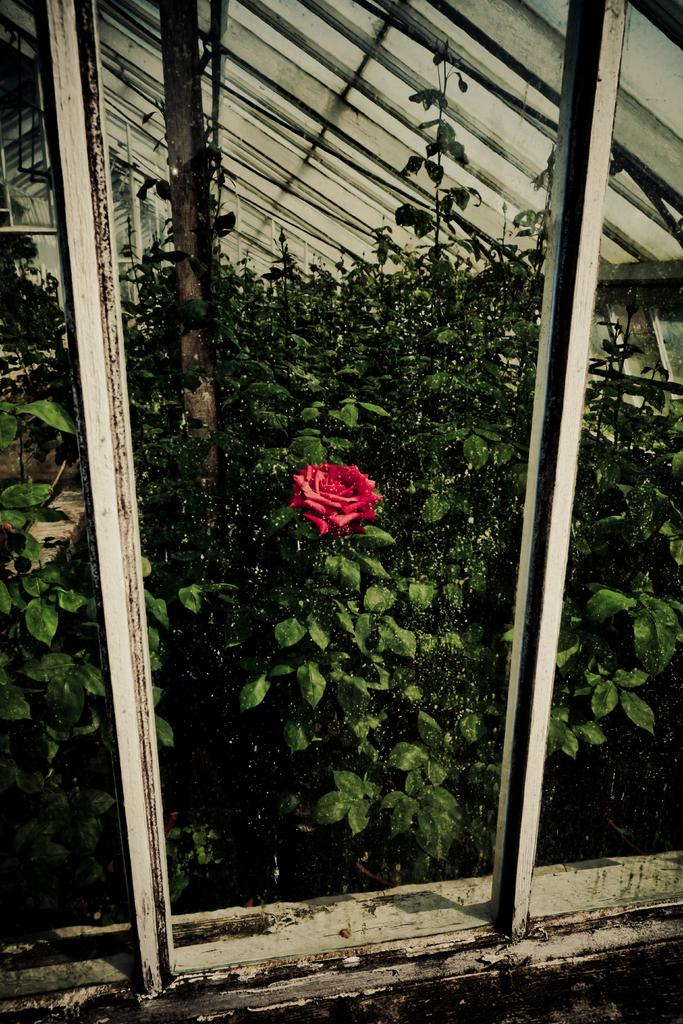What type of objects can be seen in the image that are made of metal? There are metal poles in the image. What type of plant is visible in the image? There is a flower on a plant in the image. How many plants are present in the image? There is a group of plants in the image. What part of a tree can be seen in the image? The bark of a tree is visible in the image. What type of structure is present with metal poles in the image? There is a roof with metal poles in the image. What type of club can be seen in the image? There is no club present in the image. Can you tell me how many tickets are visible in the image? There are no tickets visible in the image. 